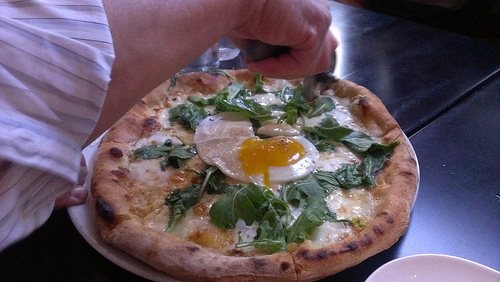Which kind of furniture is this, a table or a cabinet? The piece of furniture visible is a table. 